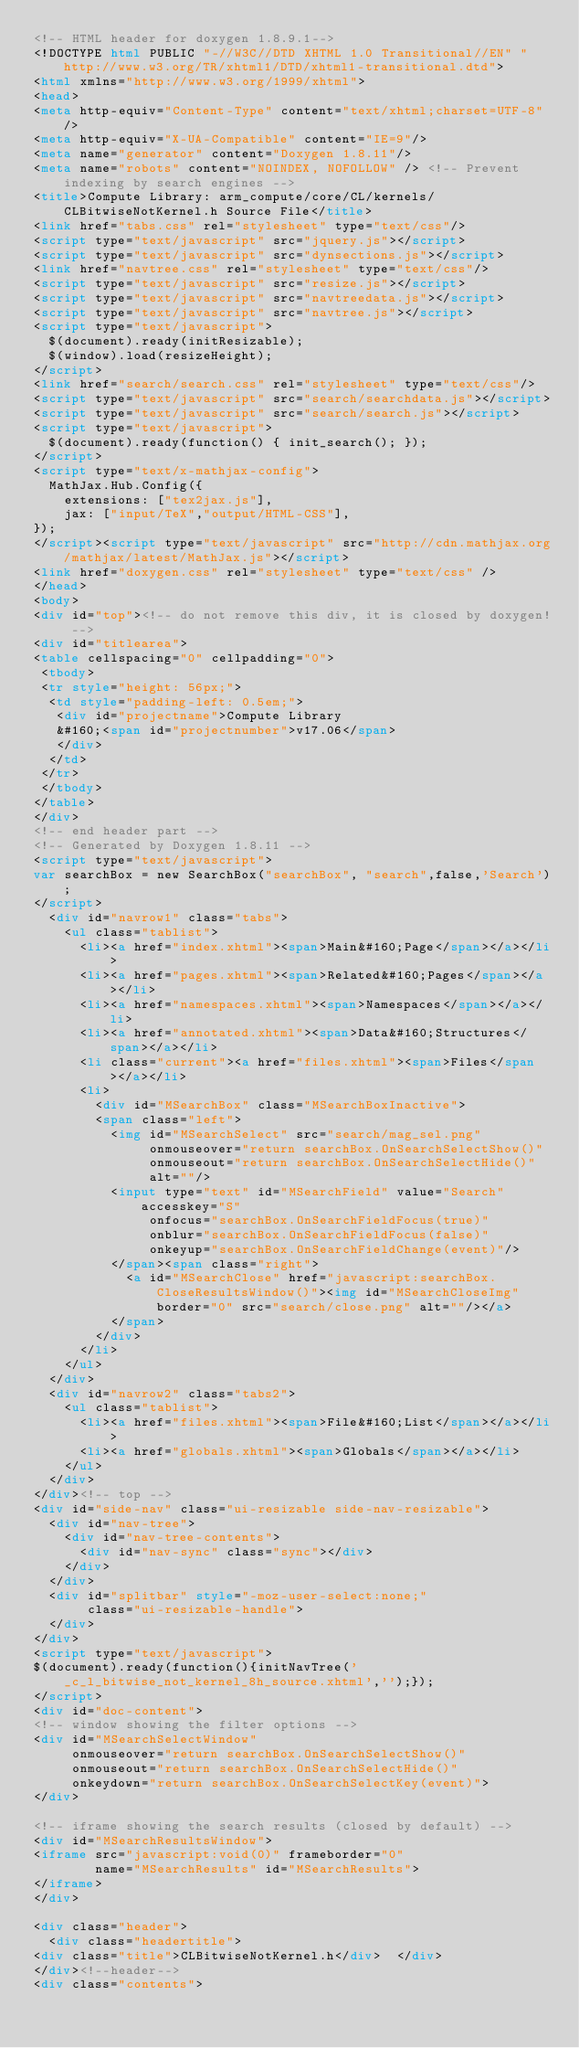Convert code to text. <code><loc_0><loc_0><loc_500><loc_500><_HTML_><!-- HTML header for doxygen 1.8.9.1-->
<!DOCTYPE html PUBLIC "-//W3C//DTD XHTML 1.0 Transitional//EN" "http://www.w3.org/TR/xhtml1/DTD/xhtml1-transitional.dtd">
<html xmlns="http://www.w3.org/1999/xhtml">
<head>
<meta http-equiv="Content-Type" content="text/xhtml;charset=UTF-8"/>
<meta http-equiv="X-UA-Compatible" content="IE=9"/>
<meta name="generator" content="Doxygen 1.8.11"/>
<meta name="robots" content="NOINDEX, NOFOLLOW" /> <!-- Prevent indexing by search engines -->
<title>Compute Library: arm_compute/core/CL/kernels/CLBitwiseNotKernel.h Source File</title>
<link href="tabs.css" rel="stylesheet" type="text/css"/>
<script type="text/javascript" src="jquery.js"></script>
<script type="text/javascript" src="dynsections.js"></script>
<link href="navtree.css" rel="stylesheet" type="text/css"/>
<script type="text/javascript" src="resize.js"></script>
<script type="text/javascript" src="navtreedata.js"></script>
<script type="text/javascript" src="navtree.js"></script>
<script type="text/javascript">
  $(document).ready(initResizable);
  $(window).load(resizeHeight);
</script>
<link href="search/search.css" rel="stylesheet" type="text/css"/>
<script type="text/javascript" src="search/searchdata.js"></script>
<script type="text/javascript" src="search/search.js"></script>
<script type="text/javascript">
  $(document).ready(function() { init_search(); });
</script>
<script type="text/x-mathjax-config">
  MathJax.Hub.Config({
    extensions: ["tex2jax.js"],
    jax: ["input/TeX","output/HTML-CSS"],
});
</script><script type="text/javascript" src="http://cdn.mathjax.org/mathjax/latest/MathJax.js"></script>
<link href="doxygen.css" rel="stylesheet" type="text/css" />
</head>
<body>
<div id="top"><!-- do not remove this div, it is closed by doxygen! -->
<div id="titlearea">
<table cellspacing="0" cellpadding="0">
 <tbody>
 <tr style="height: 56px;">
  <td style="padding-left: 0.5em;">
   <div id="projectname">Compute Library
   &#160;<span id="projectnumber">v17.06</span>
   </div>
  </td>
 </tr>
 </tbody>
</table>
</div>
<!-- end header part -->
<!-- Generated by Doxygen 1.8.11 -->
<script type="text/javascript">
var searchBox = new SearchBox("searchBox", "search",false,'Search');
</script>
  <div id="navrow1" class="tabs">
    <ul class="tablist">
      <li><a href="index.xhtml"><span>Main&#160;Page</span></a></li>
      <li><a href="pages.xhtml"><span>Related&#160;Pages</span></a></li>
      <li><a href="namespaces.xhtml"><span>Namespaces</span></a></li>
      <li><a href="annotated.xhtml"><span>Data&#160;Structures</span></a></li>
      <li class="current"><a href="files.xhtml"><span>Files</span></a></li>
      <li>
        <div id="MSearchBox" class="MSearchBoxInactive">
        <span class="left">
          <img id="MSearchSelect" src="search/mag_sel.png"
               onmouseover="return searchBox.OnSearchSelectShow()"
               onmouseout="return searchBox.OnSearchSelectHide()"
               alt=""/>
          <input type="text" id="MSearchField" value="Search" accesskey="S"
               onfocus="searchBox.OnSearchFieldFocus(true)" 
               onblur="searchBox.OnSearchFieldFocus(false)" 
               onkeyup="searchBox.OnSearchFieldChange(event)"/>
          </span><span class="right">
            <a id="MSearchClose" href="javascript:searchBox.CloseResultsWindow()"><img id="MSearchCloseImg" border="0" src="search/close.png" alt=""/></a>
          </span>
        </div>
      </li>
    </ul>
  </div>
  <div id="navrow2" class="tabs2">
    <ul class="tablist">
      <li><a href="files.xhtml"><span>File&#160;List</span></a></li>
      <li><a href="globals.xhtml"><span>Globals</span></a></li>
    </ul>
  </div>
</div><!-- top -->
<div id="side-nav" class="ui-resizable side-nav-resizable">
  <div id="nav-tree">
    <div id="nav-tree-contents">
      <div id="nav-sync" class="sync"></div>
    </div>
  </div>
  <div id="splitbar" style="-moz-user-select:none;" 
       class="ui-resizable-handle">
  </div>
</div>
<script type="text/javascript">
$(document).ready(function(){initNavTree('_c_l_bitwise_not_kernel_8h_source.xhtml','');});
</script>
<div id="doc-content">
<!-- window showing the filter options -->
<div id="MSearchSelectWindow"
     onmouseover="return searchBox.OnSearchSelectShow()"
     onmouseout="return searchBox.OnSearchSelectHide()"
     onkeydown="return searchBox.OnSearchSelectKey(event)">
</div>

<!-- iframe showing the search results (closed by default) -->
<div id="MSearchResultsWindow">
<iframe src="javascript:void(0)" frameborder="0" 
        name="MSearchResults" id="MSearchResults">
</iframe>
</div>

<div class="header">
  <div class="headertitle">
<div class="title">CLBitwiseNotKernel.h</div>  </div>
</div><!--header-->
<div class="contents"></code> 